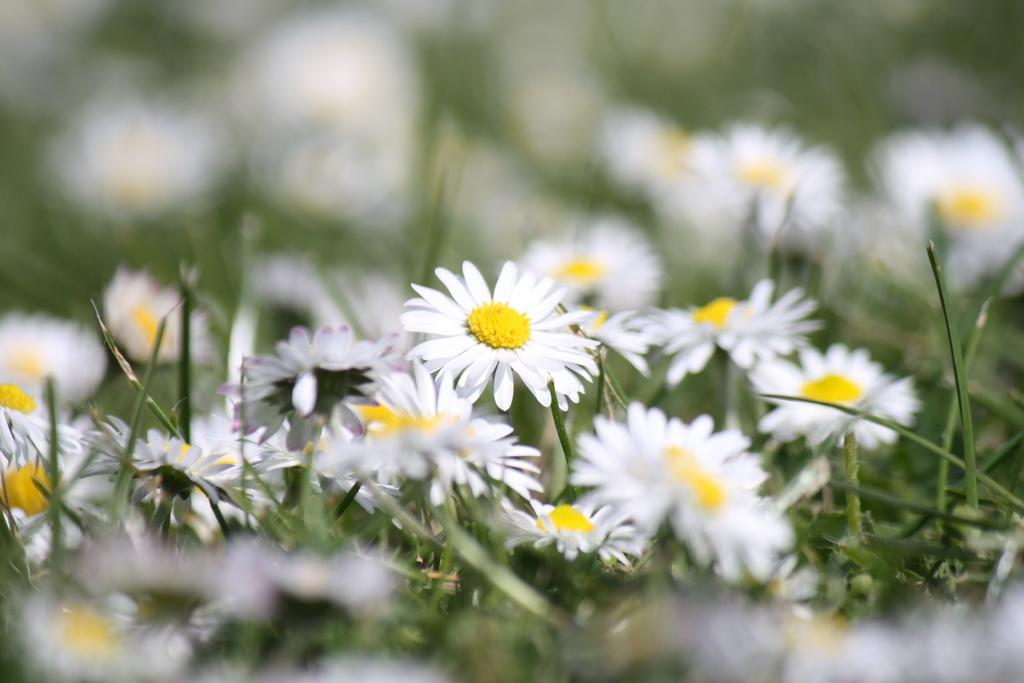What type of plants can be seen in the image? There are plants with flowers in the image. Can you describe the background of the image? The background of the image is blurred. What type of mask is being worn by the plants in the image? There are no masks present in the image, as it features plants with flowers. How are the plants being sorted in the image? The plants are not being sorted in the image; they are simply growing with flowers. 